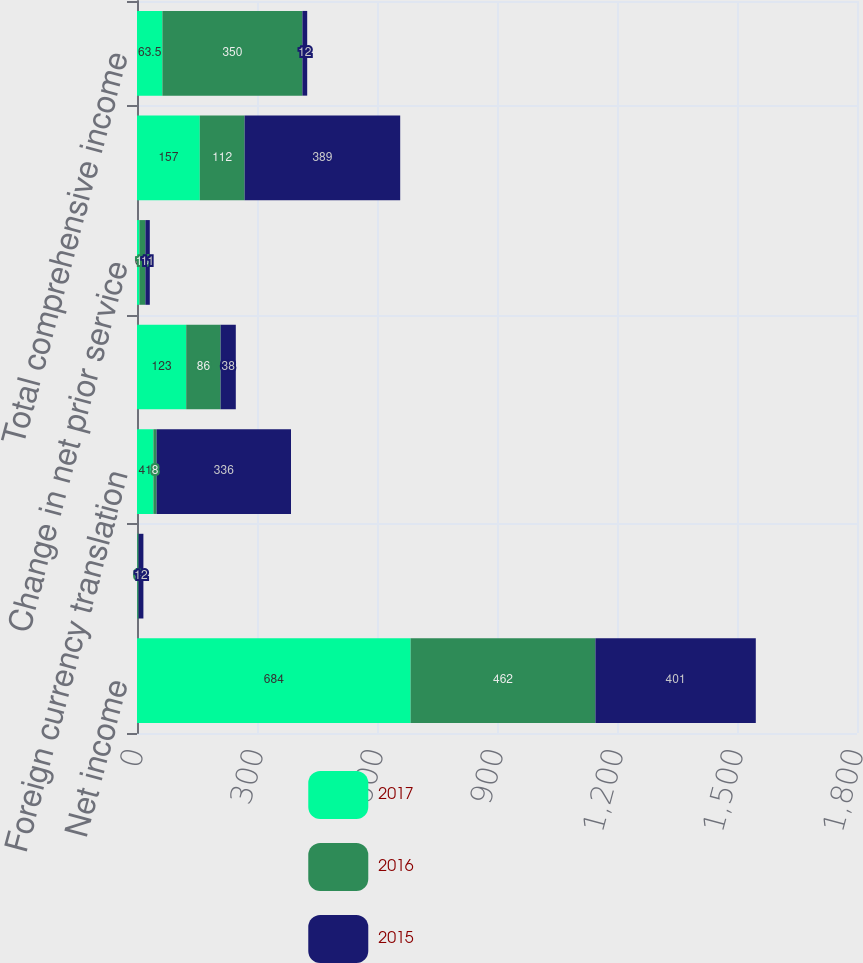Convert chart. <chart><loc_0><loc_0><loc_500><loc_500><stacked_bar_chart><ecel><fcel>Net income<fcel>Amounts reclassified into<fcel>Foreign currency translation<fcel>Change in actuarial net loss<fcel>Change in net prior service<fcel>Other comprehensive income<fcel>Total comprehensive income<nl><fcel>2017<fcel>684<fcel>1<fcel>41<fcel>123<fcel>6<fcel>157<fcel>63.5<nl><fcel>2016<fcel>462<fcel>3<fcel>8<fcel>86<fcel>15<fcel>112<fcel>350<nl><fcel>2015<fcel>401<fcel>12<fcel>336<fcel>38<fcel>11<fcel>389<fcel>12<nl></chart> 